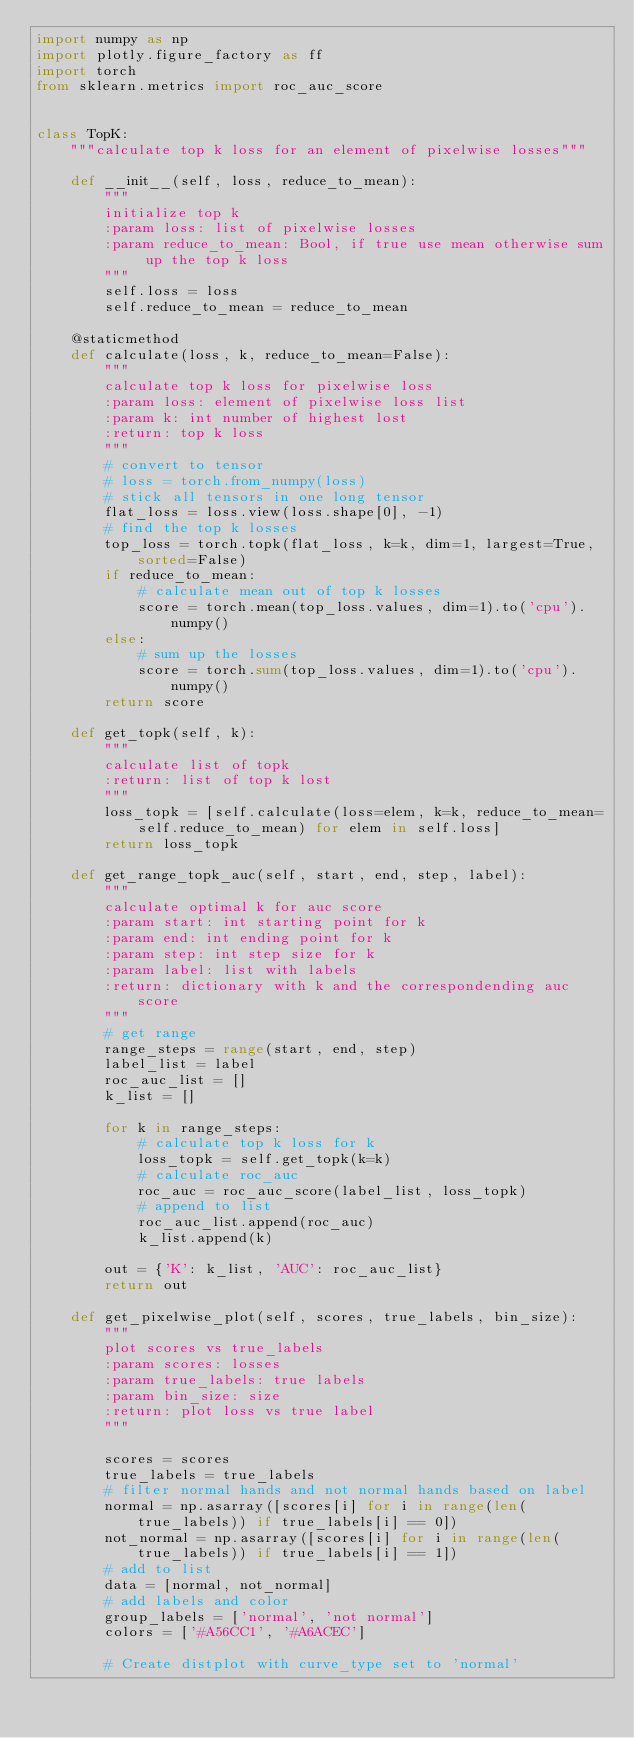Convert code to text. <code><loc_0><loc_0><loc_500><loc_500><_Python_>import numpy as np
import plotly.figure_factory as ff
import torch
from sklearn.metrics import roc_auc_score


class TopK:
    """calculate top k loss for an element of pixelwise losses"""

    def __init__(self, loss, reduce_to_mean):
        """
        initialize top k
        :param loss: list of pixelwise losses
        :param reduce_to_mean: Bool, if true use mean otherwise sum up the top k loss
        """
        self.loss = loss
        self.reduce_to_mean = reduce_to_mean

    @staticmethod
    def calculate(loss, k, reduce_to_mean=False):
        """
        calculate top k loss for pixelwise loss
        :param loss: element of pixelwise loss list
        :param k: int number of highest lost
        :return: top k loss
        """
        # convert to tensor
        # loss = torch.from_numpy(loss)
        # stick all tensors in one long tensor
        flat_loss = loss.view(loss.shape[0], -1)
        # find the top k losses
        top_loss = torch.topk(flat_loss, k=k, dim=1, largest=True, sorted=False)
        if reduce_to_mean:
            # calculate mean out of top k losses
            score = torch.mean(top_loss.values, dim=1).to('cpu').numpy()
        else:
            # sum up the losses
            score = torch.sum(top_loss.values, dim=1).to('cpu').numpy()
        return score

    def get_topk(self, k):
        """
        calculate list of topk
        :return: list of top k lost
        """
        loss_topk = [self.calculate(loss=elem, k=k, reduce_to_mean=self.reduce_to_mean) for elem in self.loss]
        return loss_topk

    def get_range_topk_auc(self, start, end, step, label):
        """
        calculate optimal k for auc score
        :param start: int starting point for k
        :param end: int ending point for k
        :param step: int step size for k
        :param label: list with labels
        :return: dictionary with k and the correspondending auc score
        """
        # get range
        range_steps = range(start, end, step)
        label_list = label
        roc_auc_list = []
        k_list = []

        for k in range_steps:
            # calculate top k loss for k
            loss_topk = self.get_topk(k=k)
            # calculate roc_auc
            roc_auc = roc_auc_score(label_list, loss_topk)
            # append to list
            roc_auc_list.append(roc_auc)
            k_list.append(k)

        out = {'K': k_list, 'AUC': roc_auc_list}
        return out

    def get_pixelwise_plot(self, scores, true_labels, bin_size):
        """
        plot scores vs true_labels
        :param scores: losses
        :param true_labels: true labels
        :param bin_size: size
        :return: plot loss vs true label
        """

        scores = scores
        true_labels = true_labels
        # filter normal hands and not normal hands based on label
        normal = np.asarray([scores[i] for i in range(len(true_labels)) if true_labels[i] == 0])
        not_normal = np.asarray([scores[i] for i in range(len(true_labels)) if true_labels[i] == 1])
        # add to list
        data = [normal, not_normal]
        # add labels and color
        group_labels = ['normal', 'not normal']
        colors = ['#A56CC1', '#A6ACEC']

        # Create distplot with curve_type set to 'normal'</code> 